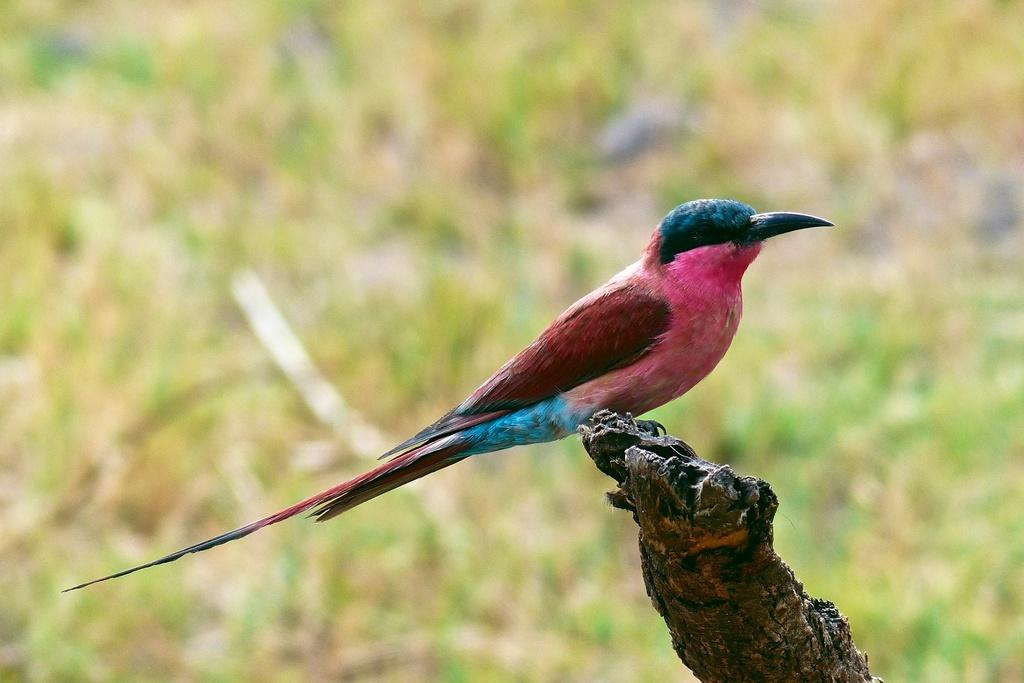What type of animal can be seen in the image? There is a bird in the image. Where is the bird located? The bird is on a branch of a tree. What can be seen at the bottom of the image? There is grass visible at the bottom of the image. What type of fruit is the bird holding in its beak in the image? There is no fruit visible in the image, and the bird is not holding anything in its beak. 